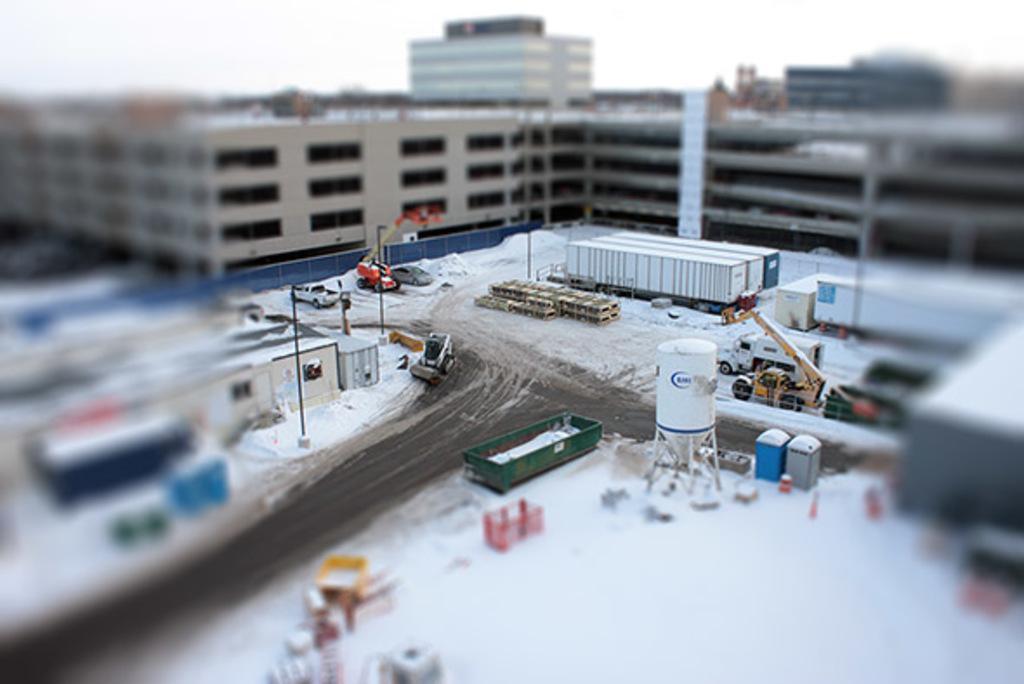Please provide a concise description of this image. In this image there are buildings, vehicles, crane, poles, sky and objects. 